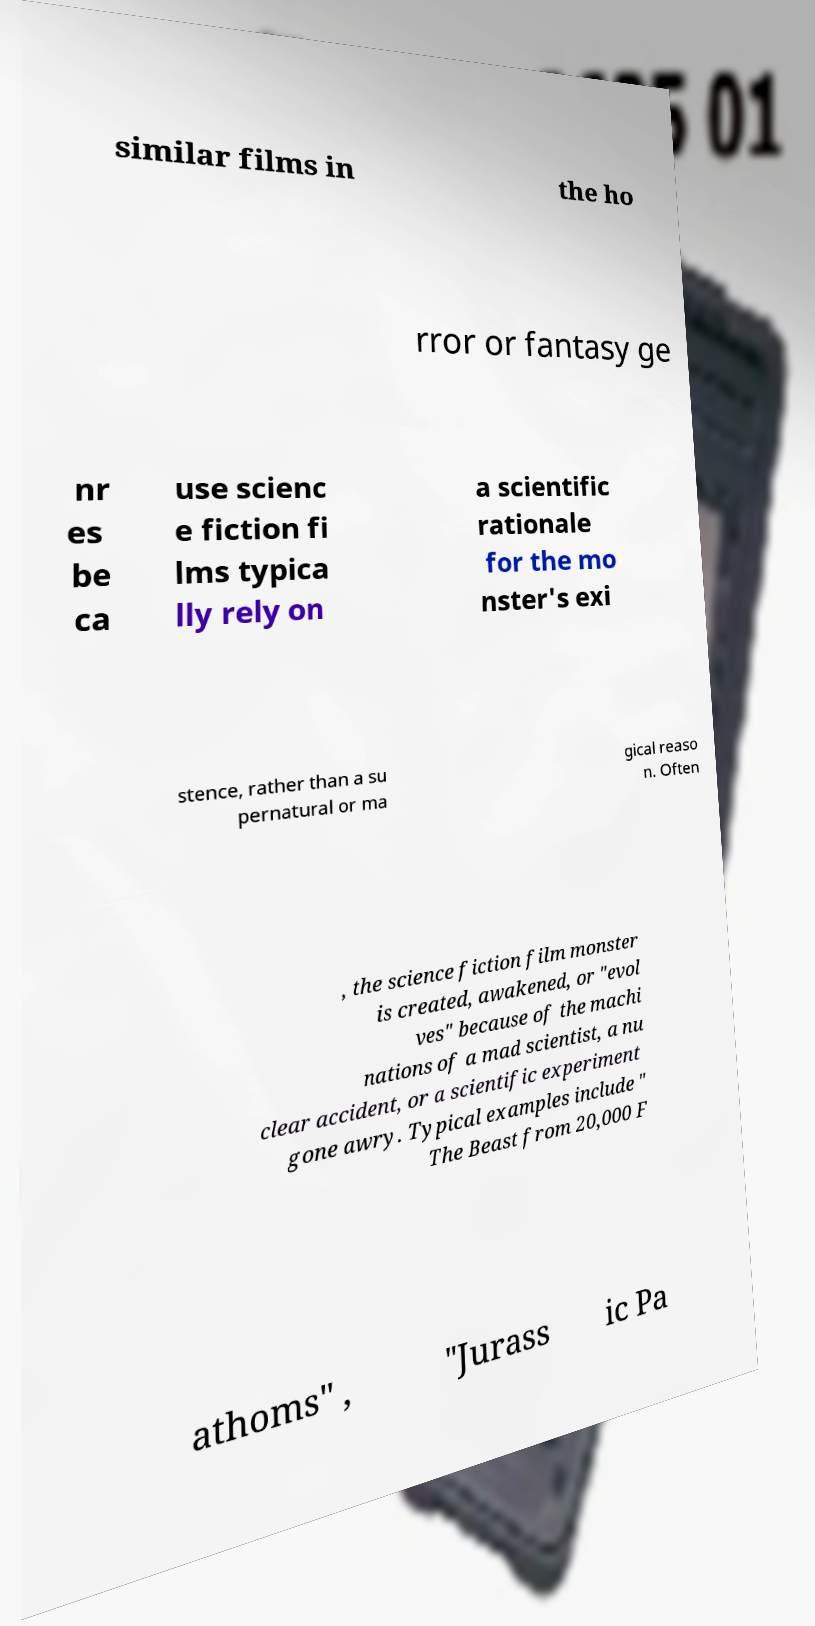Could you assist in decoding the text presented in this image and type it out clearly? similar films in the ho rror or fantasy ge nr es be ca use scienc e fiction fi lms typica lly rely on a scientific rationale for the mo nster's exi stence, rather than a su pernatural or ma gical reaso n. Often , the science fiction film monster is created, awakened, or "evol ves" because of the machi nations of a mad scientist, a nu clear accident, or a scientific experiment gone awry. Typical examples include " The Beast from 20,000 F athoms" , "Jurass ic Pa 